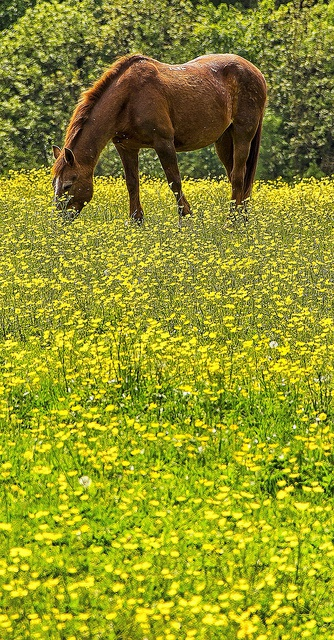Describe the objects in this image and their specific colors. I can see a horse in black, maroon, and brown tones in this image. 